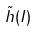<formula> <loc_0><loc_0><loc_500><loc_500>\tilde { h } ( I )</formula> 